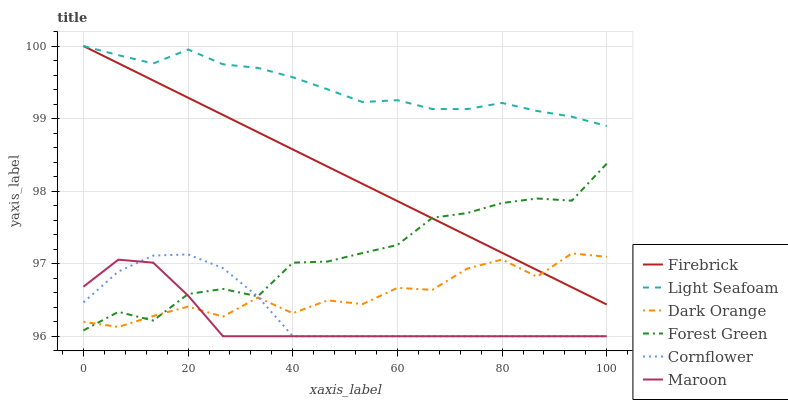Does Maroon have the minimum area under the curve?
Answer yes or no. Yes. Does Light Seafoam have the maximum area under the curve?
Answer yes or no. Yes. Does Cornflower have the minimum area under the curve?
Answer yes or no. No. Does Cornflower have the maximum area under the curve?
Answer yes or no. No. Is Firebrick the smoothest?
Answer yes or no. Yes. Is Dark Orange the roughest?
Answer yes or no. Yes. Is Cornflower the smoothest?
Answer yes or no. No. Is Cornflower the roughest?
Answer yes or no. No. Does Cornflower have the lowest value?
Answer yes or no. Yes. Does Firebrick have the lowest value?
Answer yes or no. No. Does Light Seafoam have the highest value?
Answer yes or no. Yes. Does Cornflower have the highest value?
Answer yes or no. No. Is Maroon less than Light Seafoam?
Answer yes or no. Yes. Is Light Seafoam greater than Cornflower?
Answer yes or no. Yes. Does Firebrick intersect Dark Orange?
Answer yes or no. Yes. Is Firebrick less than Dark Orange?
Answer yes or no. No. Is Firebrick greater than Dark Orange?
Answer yes or no. No. Does Maroon intersect Light Seafoam?
Answer yes or no. No. 